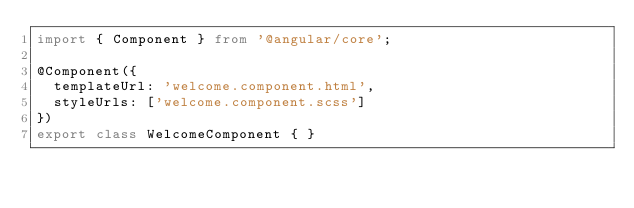<code> <loc_0><loc_0><loc_500><loc_500><_TypeScript_>import { Component } from '@angular/core';

@Component({
  templateUrl: 'welcome.component.html',
  styleUrls: ['welcome.component.scss']
})
export class WelcomeComponent { }
</code> 